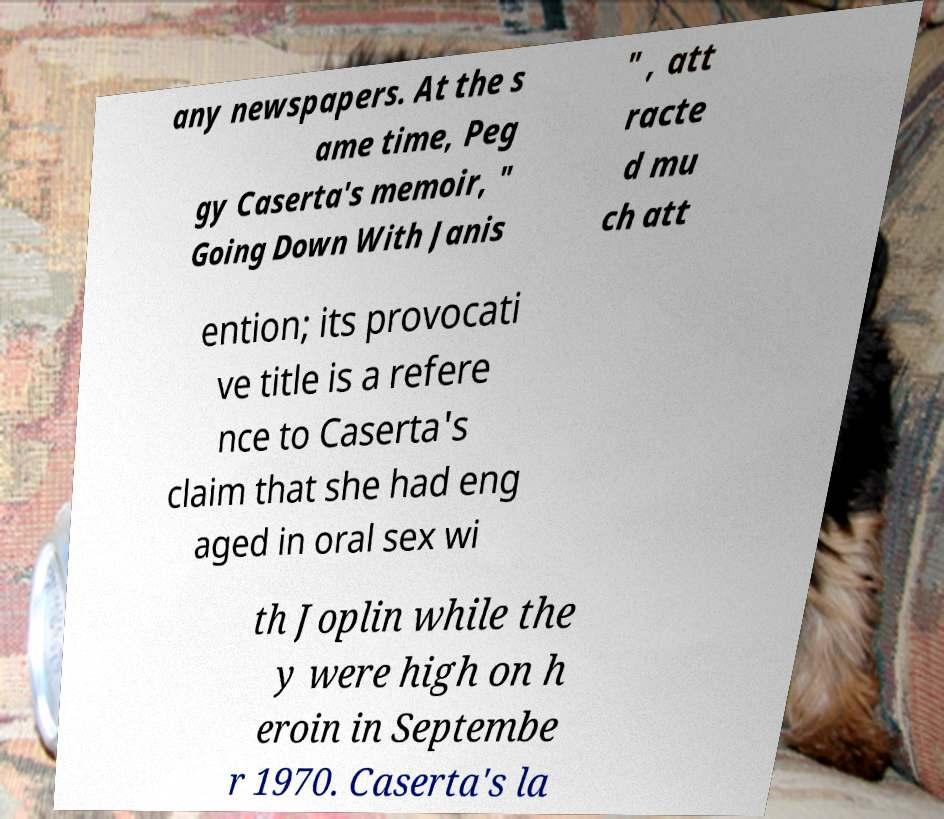Please identify and transcribe the text found in this image. any newspapers. At the s ame time, Peg gy Caserta's memoir, " Going Down With Janis " , att racte d mu ch att ention; its provocati ve title is a refere nce to Caserta's claim that she had eng aged in oral sex wi th Joplin while the y were high on h eroin in Septembe r 1970. Caserta's la 